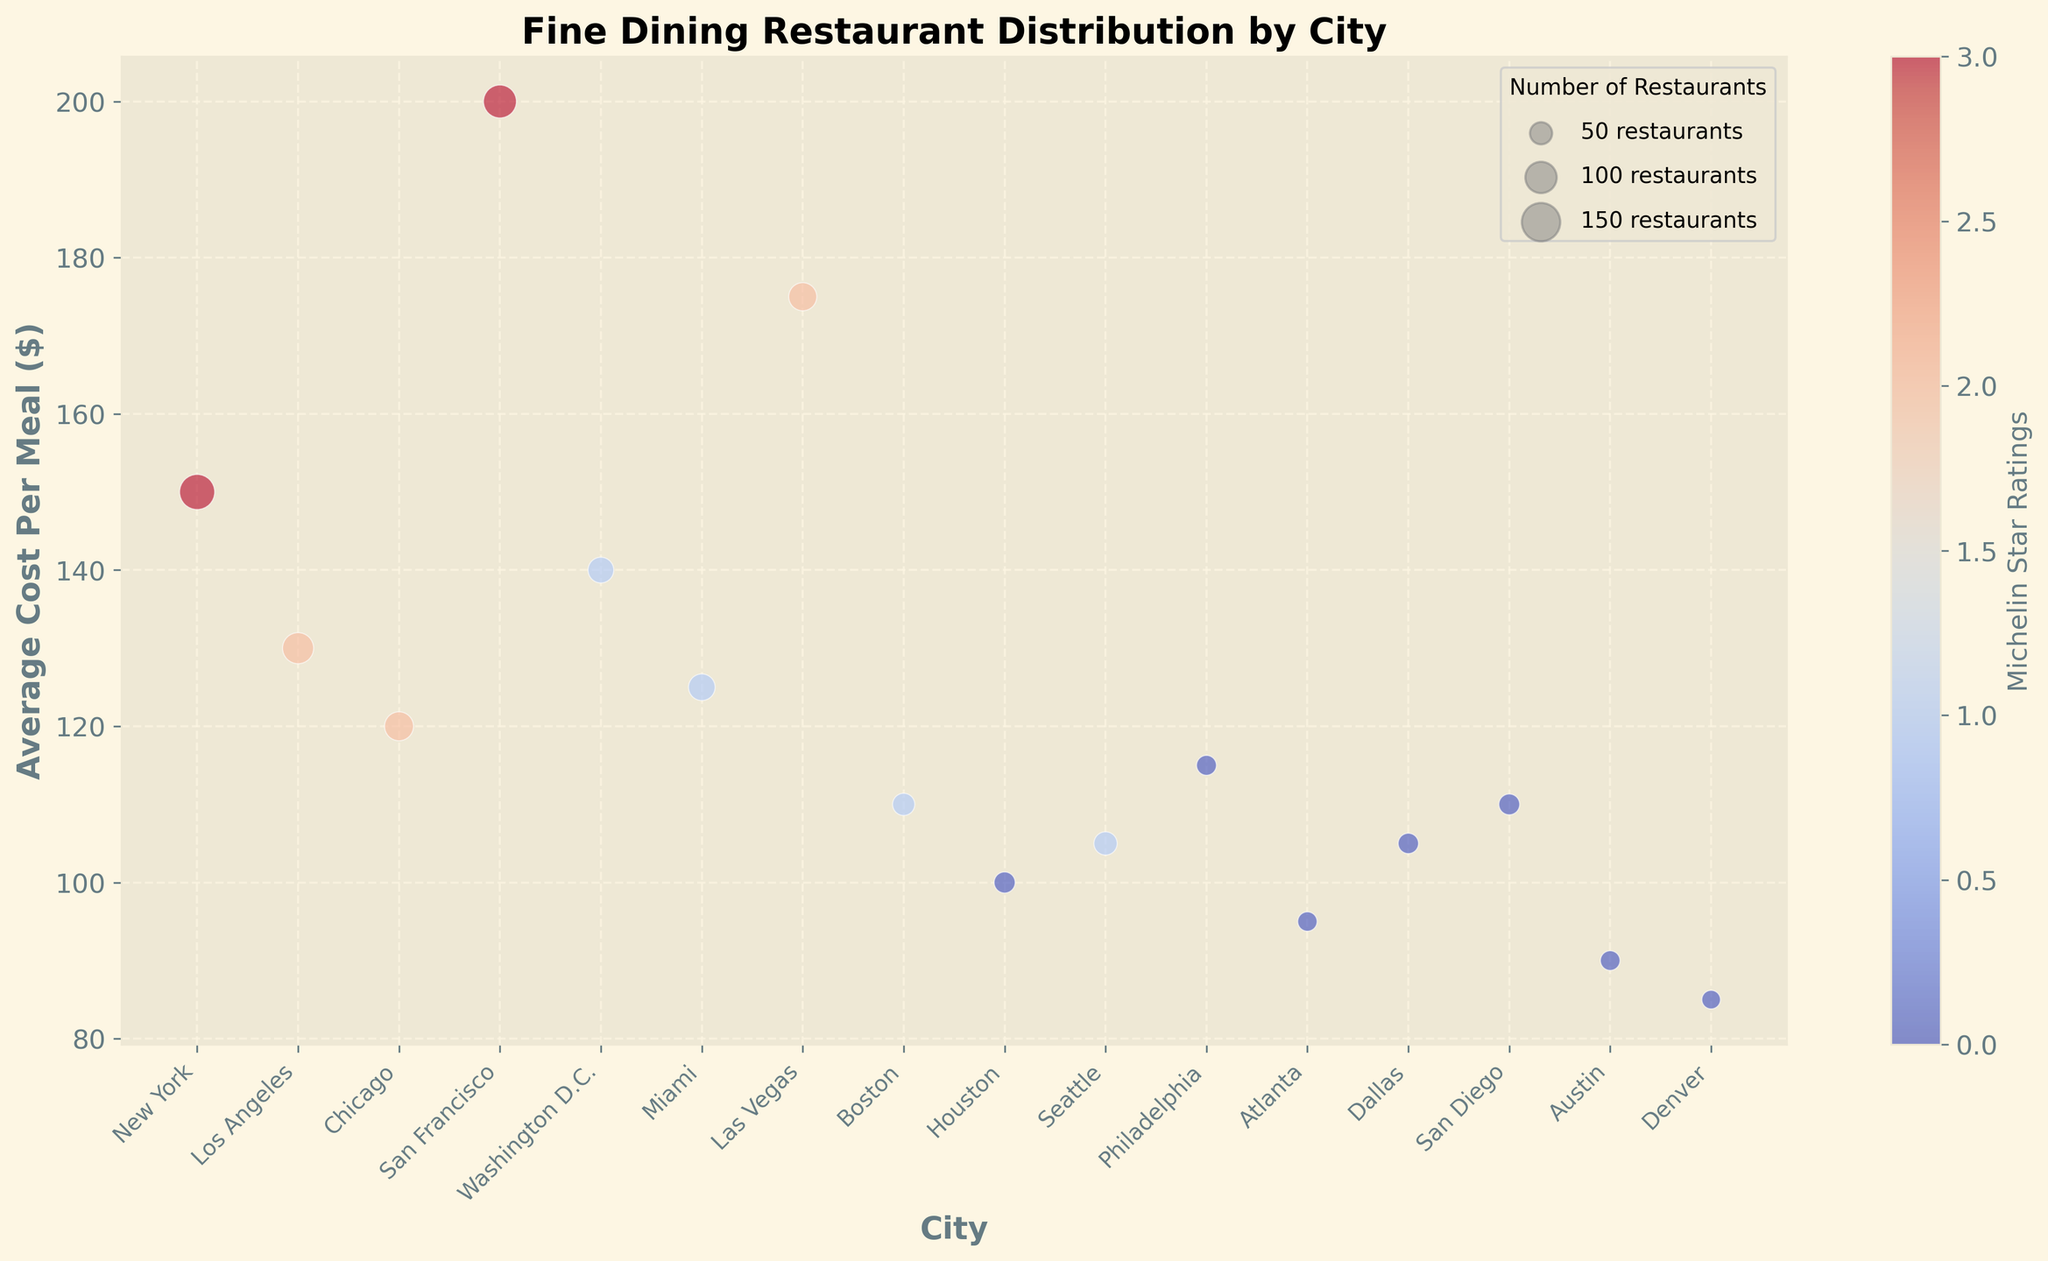What city has the highest average cost per meal? By looking at the y-axis, identify which city's bubble is highest up on the plot.
Answer: San Francisco Which city has the most fine dining restaurants? Look at the bubble size. The largest bubble indicates the city with the highest number of restaurants.
Answer: New York What is the relationship between average cost per meal and Michelin star ratings in Las Vegas compared to Miami? Find the bubbles for both cities and compare their y-axis positions and color intensity. Las Vegas (higher, darker) vs. Miami (lower, lighter).
Answer: Las Vegas has a higher average cost and higher Michelin star rating How many restaurants are in cities with a Michelin star rating of 1? Count the bubbles with a lighter color (indicating a Michelin star rating of 1) and sum the values represented by the bubble sizes. Washington D.C., Miami, Boston, Seattle have 67, 72, 50, 55 restaurants, respectively. 67 + 72 + 50 + 55 = 244
Answer: 244 Which city has the largest difference in average cost per meal compared to New York? First, note New York’s average cost per meal (150). Compare it to the average costs in other cities and find the one with the furthest value. Difference: San Francisco (200-150=50), Las Vegas (175-150=25), etc.
Answer: San Francisco Which cities do not have any Michelin star ratings and what are their average costs per meal? Identify the bubbles with the lightest color (indicating a rating of 0) and note their average costs. Houston (100), Philadelphia (115), Atlanta (95), Dallas (105), San Diego (110), Austin (90), Denver (85)
Answer: Houston (100), Philadelphia (115), Atlanta (95), Dallas (105), San Diego (110), Austin (90), Denver (85) Comparing Los Angeles and Chicago, which city has a higher average cost per meal and Michelin star rating? Identify both bubbles; compare their y-axis height and color intensity.
Answer: Los Angeles has a higher average cost per meal (130 vs. 120) and the same Michelin star rating (2 each) What is the sum of the average cost per meal for cities with the highest Michelin star ratings? Find cities with Michelin star rating of 3 (darkest bubbles): New York (150) and San Francisco (200). Sum these values. 150 + 200 = 350
Answer: 350 What's the average number of restaurants in cities with an average cost per meal below $100? Identify bubbles below $100 on the y-axis: Atlanta (38), Austin (39), Denver (35). Total restaurants: 38 + 39 + 35 = 112, average = 112 / 3 = ~37.33
Answer: ~37.33 